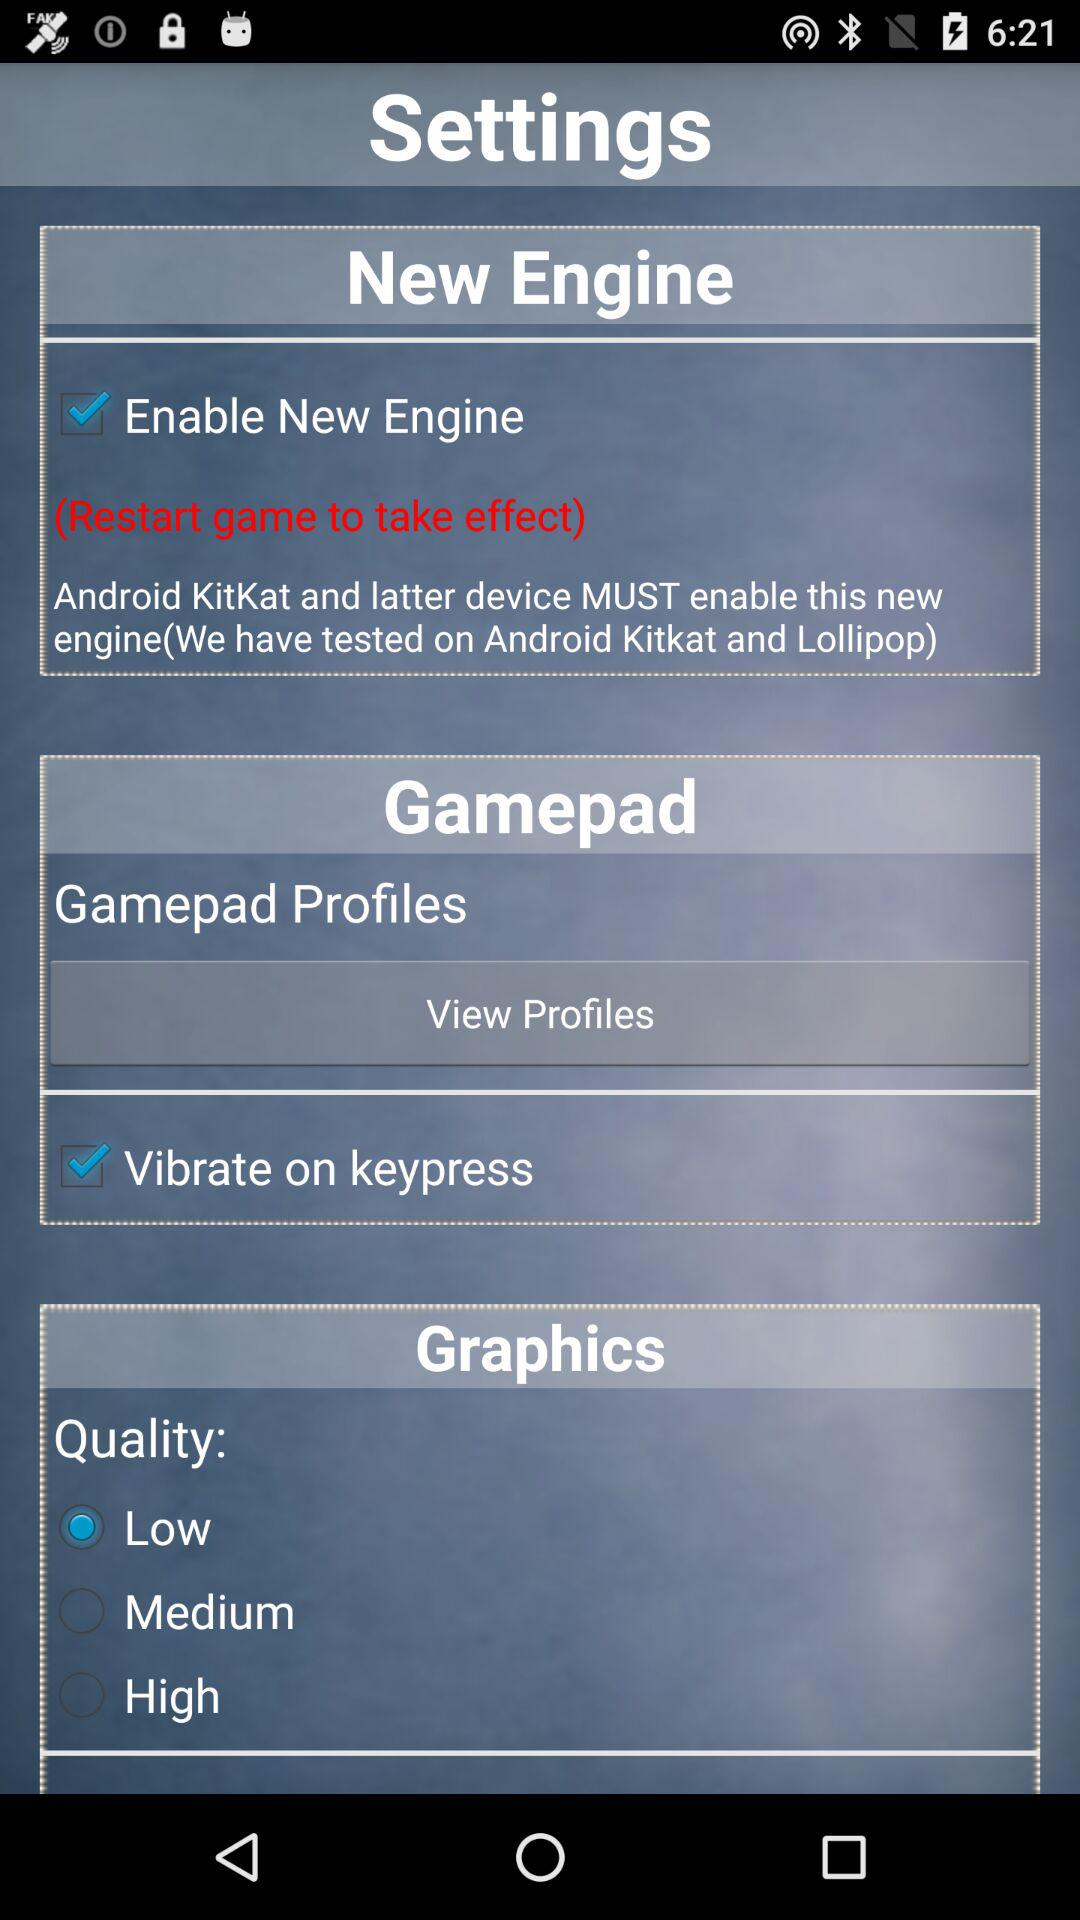What is the selected option for "Quality"? The selected option is "Low". 